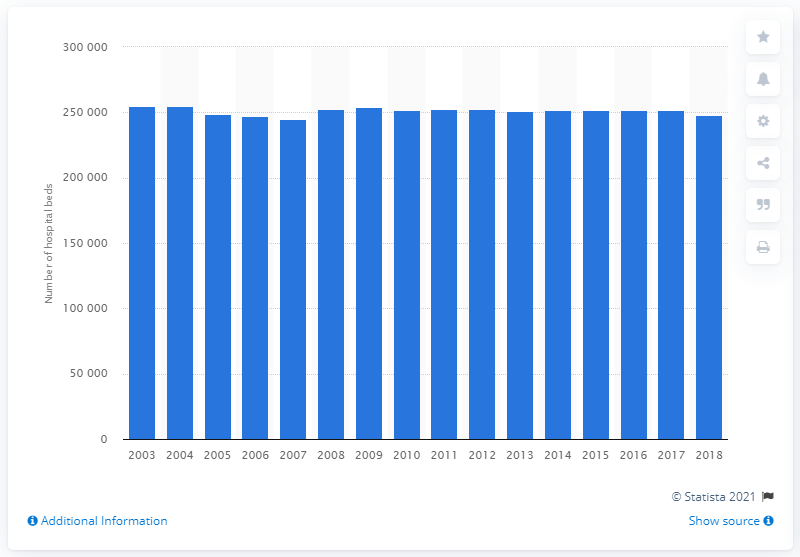Specify some key components in this picture. There were 248,239 hospital beds in Poland in 2003. In 2017, the number of hospital beds in Poland was 251,537. In the last 14 years, there has been a significant decrease in the number of hospital beds in Poland, with a total of 251,537 fewer beds available as of today. 